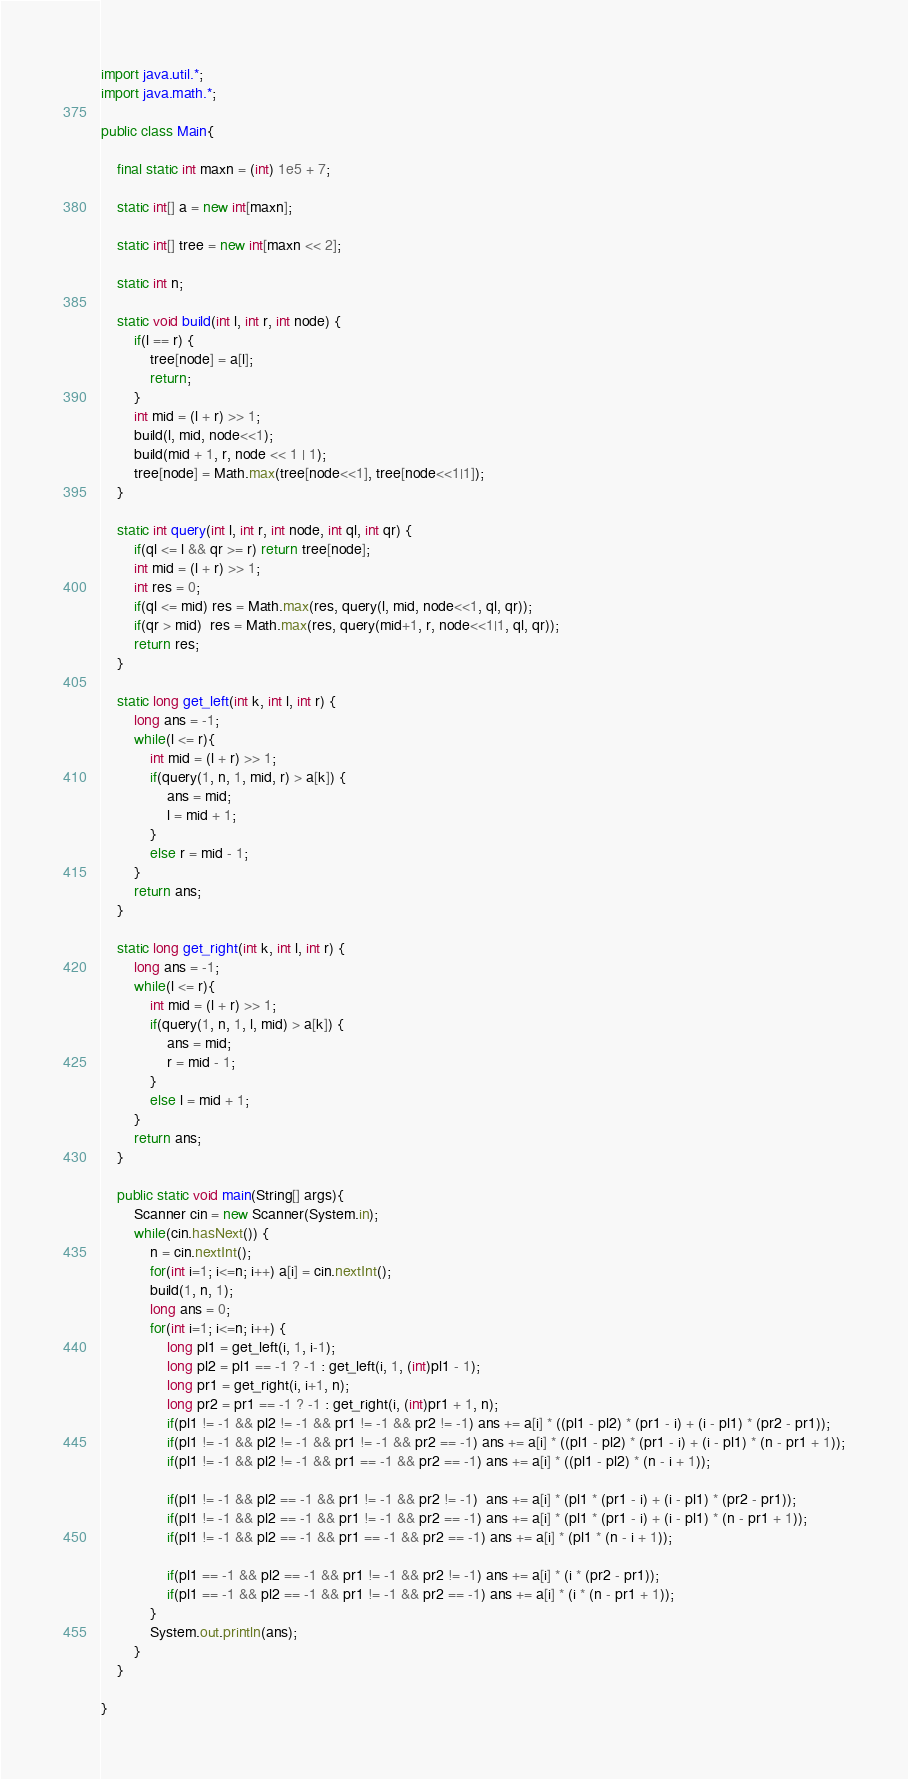<code> <loc_0><loc_0><loc_500><loc_500><_Java_>
import java.util.*;
import java.math.*;

public class Main{

    final static int maxn = (int) 1e5 + 7;

    static int[] a = new int[maxn];

    static int[] tree = new int[maxn << 2];

    static int n;

    static void build(int l, int r, int node) {
        if(l == r) {
            tree[node] = a[l];
            return;
        }
        int mid = (l + r) >> 1;
        build(l, mid, node<<1);
        build(mid + 1, r, node << 1 | 1);
        tree[node] = Math.max(tree[node<<1], tree[node<<1|1]);
    }

    static int query(int l, int r, int node, int ql, int qr) {
        if(ql <= l && qr >= r) return tree[node];
        int mid = (l + r) >> 1;
        int res = 0;
        if(ql <= mid) res = Math.max(res, query(l, mid, node<<1, ql, qr));
        if(qr > mid)  res = Math.max(res, query(mid+1, r, node<<1|1, ql, qr));
        return res;
    }

    static long get_left(int k, int l, int r) {
        long ans = -1;
        while(l <= r){
            int mid = (l + r) >> 1;
            if(query(1, n, 1, mid, r) > a[k]) {
                ans = mid;
                l = mid + 1;
            }
            else r = mid - 1;
        }
        return ans;
    }

    static long get_right(int k, int l, int r) {
        long ans = -1;
        while(l <= r){
            int mid = (l + r) >> 1;
            if(query(1, n, 1, l, mid) > a[k]) {
                ans = mid;
                r = mid - 1;
            }
            else l = mid + 1;
        }
        return ans;
    }

    public static void main(String[] args){
        Scanner cin = new Scanner(System.in);
        while(cin.hasNext()) {
            n = cin.nextInt();
            for(int i=1; i<=n; i++) a[i] = cin.nextInt();
            build(1, n, 1);
            long ans = 0;
            for(int i=1; i<=n; i++) {
                long pl1 = get_left(i, 1, i-1);
                long pl2 = pl1 == -1 ? -1 : get_left(i, 1, (int)pl1 - 1);
                long pr1 = get_right(i, i+1, n);
                long pr2 = pr1 == -1 ? -1 : get_right(i, (int)pr1 + 1, n);
                if(pl1 != -1 && pl2 != -1 && pr1 != -1 && pr2 != -1) ans += a[i] * ((pl1 - pl2) * (pr1 - i) + (i - pl1) * (pr2 - pr1));
                if(pl1 != -1 && pl2 != -1 && pr1 != -1 && pr2 == -1) ans += a[i] * ((pl1 - pl2) * (pr1 - i) + (i - pl1) * (n - pr1 + 1));
                if(pl1 != -1 && pl2 != -1 && pr1 == -1 && pr2 == -1) ans += a[i] * ((pl1 - pl2) * (n - i + 1));

                if(pl1 != -1 && pl2 == -1 && pr1 != -1 && pr2 != -1)  ans += a[i] * (pl1 * (pr1 - i) + (i - pl1) * (pr2 - pr1));
                if(pl1 != -1 && pl2 == -1 && pr1 != -1 && pr2 == -1) ans += a[i] * (pl1 * (pr1 - i) + (i - pl1) * (n - pr1 + 1));
                if(pl1 != -1 && pl2 == -1 && pr1 == -1 && pr2 == -1) ans += a[i] * (pl1 * (n - i + 1));

                if(pl1 == -1 && pl2 == -1 && pr1 != -1 && pr2 != -1) ans += a[i] * (i * (pr2 - pr1));
                if(pl1 == -1 && pl2 == -1 && pr1 != -1 && pr2 == -1) ans += a[i] * (i * (n - pr1 + 1));
            }
            System.out.println(ans);
        }
    }

}

















</code> 